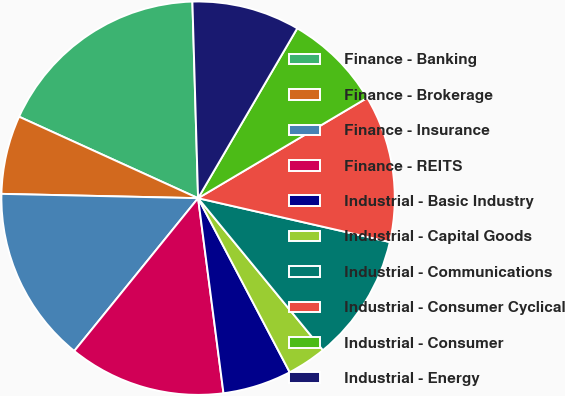<chart> <loc_0><loc_0><loc_500><loc_500><pie_chart><fcel>Finance - Banking<fcel>Finance - Brokerage<fcel>Finance - Insurance<fcel>Finance - REITS<fcel>Industrial - Basic Industry<fcel>Industrial - Capital Goods<fcel>Industrial - Communications<fcel>Industrial - Consumer Cyclical<fcel>Industrial - Consumer<fcel>Industrial - Energy<nl><fcel>17.74%<fcel>6.45%<fcel>14.51%<fcel>12.9%<fcel>5.65%<fcel>3.23%<fcel>10.48%<fcel>12.1%<fcel>8.07%<fcel>8.87%<nl></chart> 